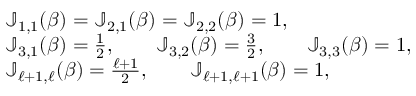<formula> <loc_0><loc_0><loc_500><loc_500>\begin{array} { r l } & { \mathbb { J } _ { 1 , 1 } ( \beta ) = \mathbb { J } _ { 2 , 1 } ( \beta ) = \mathbb { J } _ { 2 , 2 } ( \beta ) = 1 , } \\ & { \mathbb { J } _ { 3 , 1 } ( \beta ) = { \frac { 1 } { 2 } } , \quad \mathbb { J } _ { 3 , 2 } ( \beta ) = { \frac { 3 } { 2 } } , \quad \mathbb { J } _ { 3 , 3 } ( \beta ) = 1 , } \\ & { \mathbb { J } _ { \ell + 1 , \ell } ( \beta ) = { \frac { \ell + 1 } { 2 } } , \quad \mathbb { J } _ { \ell + 1 , \ell + 1 } ( \beta ) = 1 , } \end{array}</formula> 